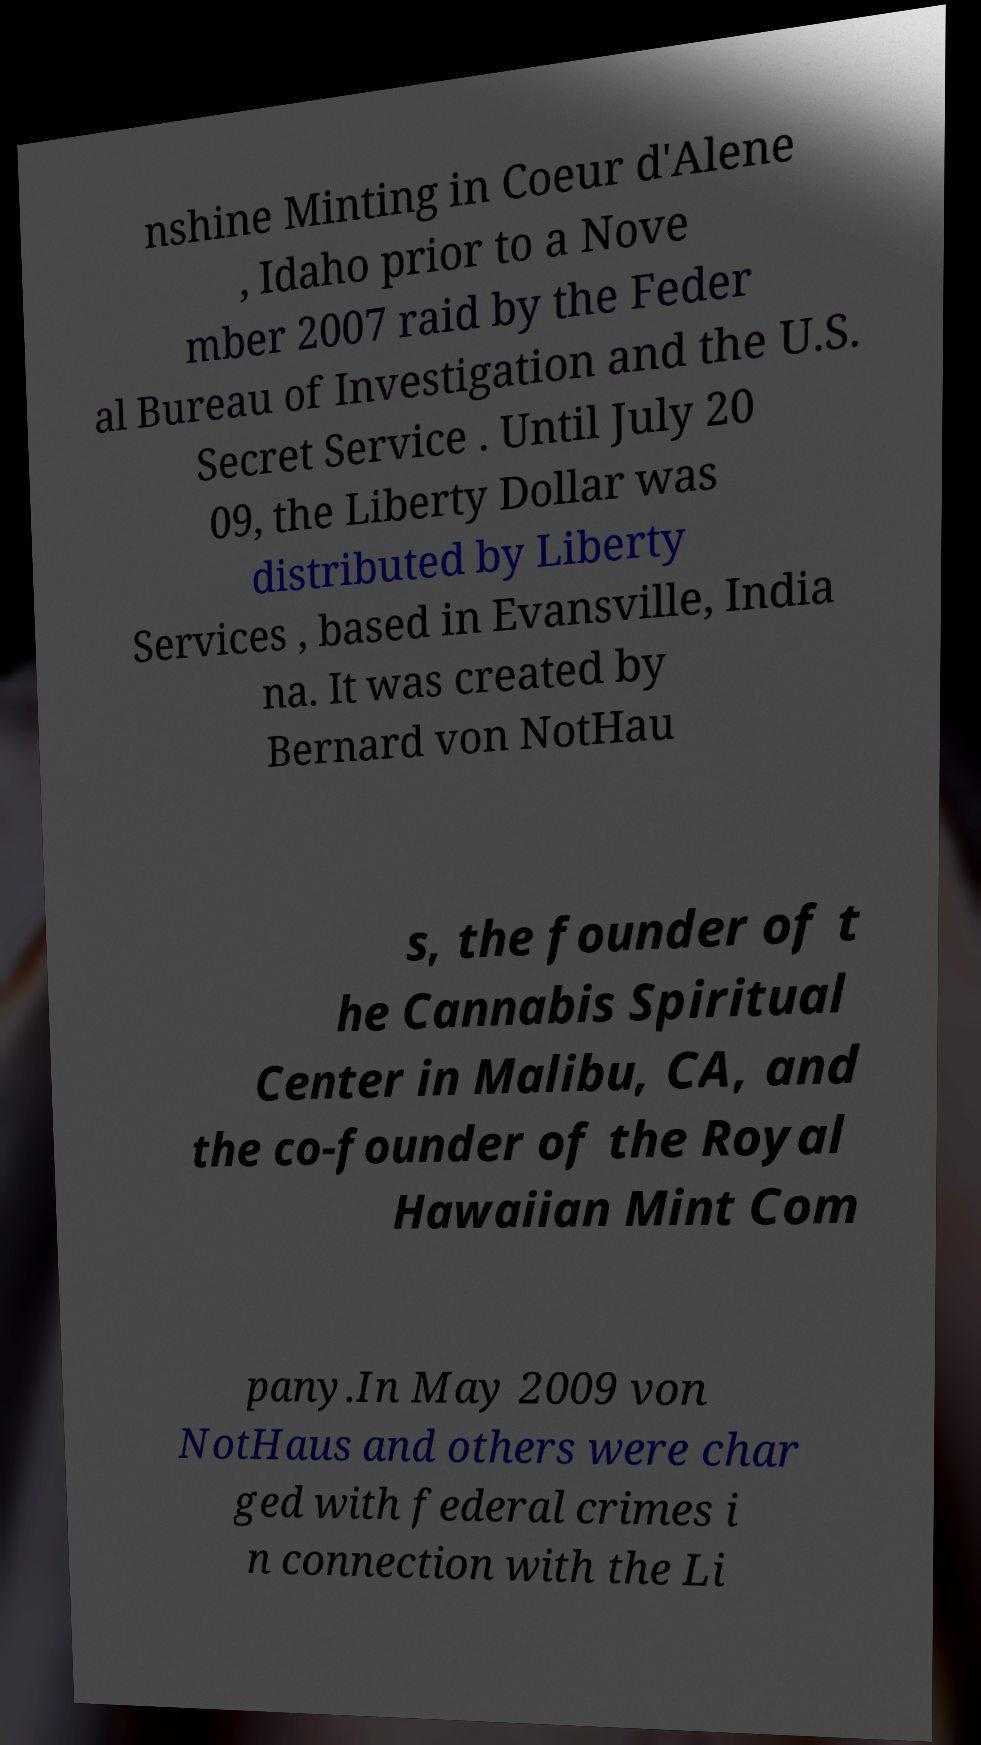Can you accurately transcribe the text from the provided image for me? nshine Minting in Coeur d'Alene , Idaho prior to a Nove mber 2007 raid by the Feder al Bureau of Investigation and the U.S. Secret Service . Until July 20 09, the Liberty Dollar was distributed by Liberty Services , based in Evansville, India na. It was created by Bernard von NotHau s, the founder of t he Cannabis Spiritual Center in Malibu, CA, and the co-founder of the Royal Hawaiian Mint Com pany.In May 2009 von NotHaus and others were char ged with federal crimes i n connection with the Li 